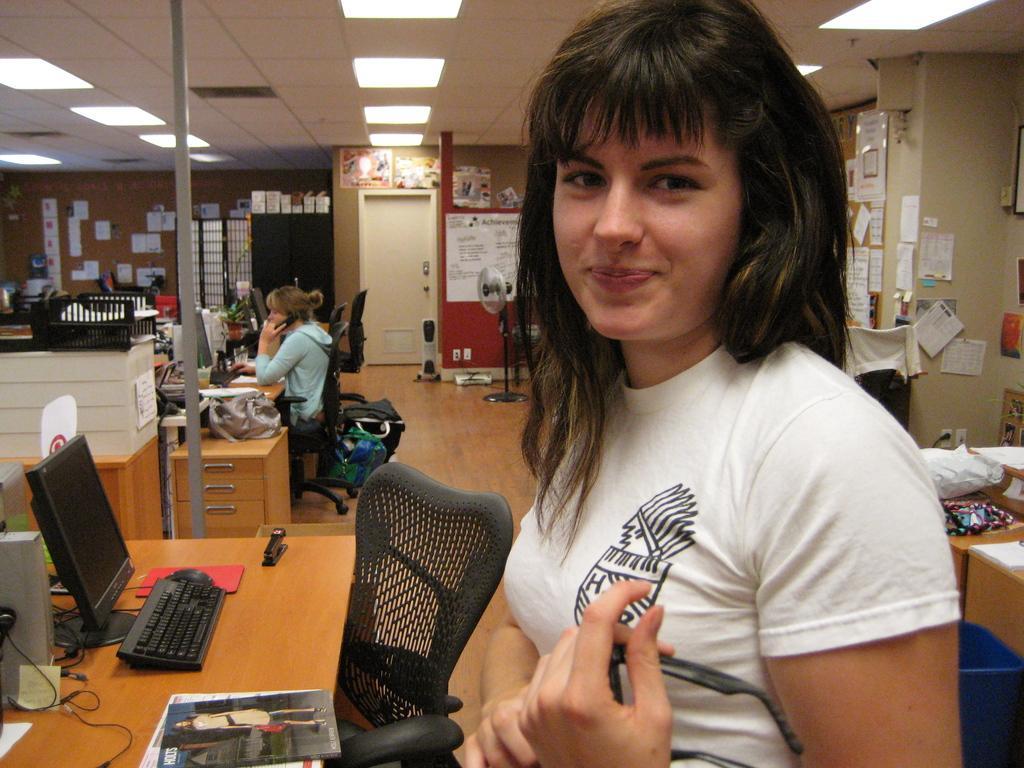Can you describe this image briefly? In this image we can see a woman standing on the right side and she is smiling. This is a wooden table where a computer and a magazine are kept on it. Here we can see a woman sitting on a chair and she is speaking on a telephone. 